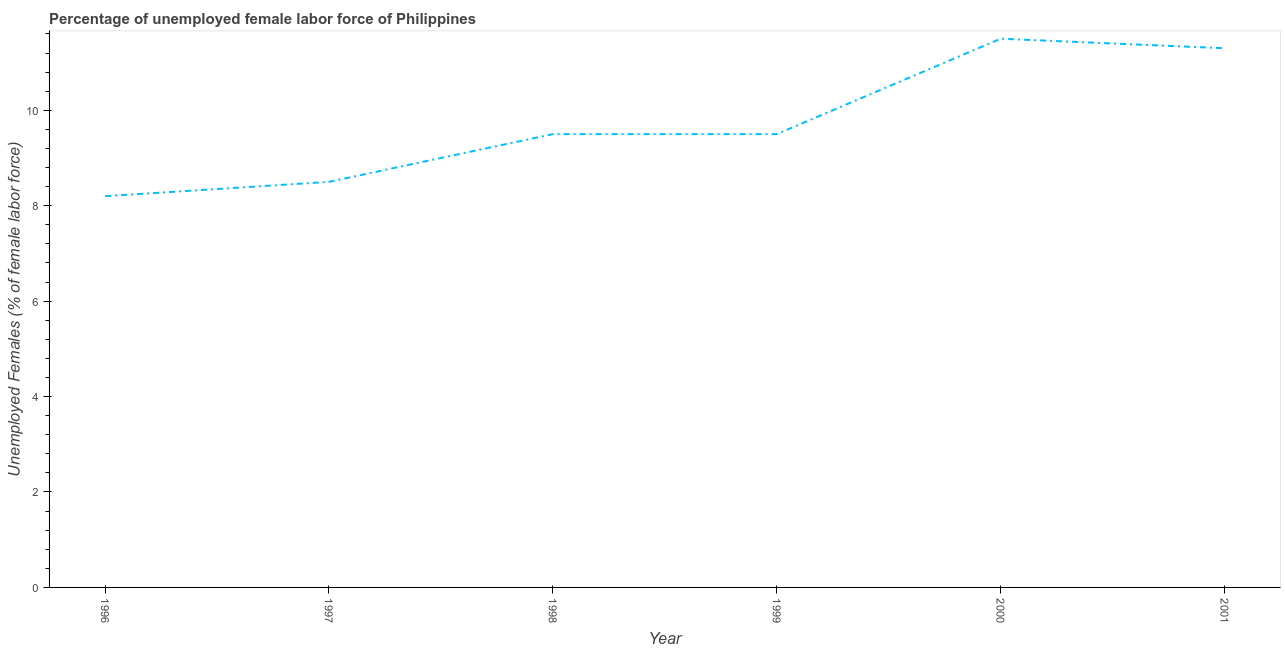What is the total unemployed female labour force in 2000?
Your response must be concise. 11.5. Across all years, what is the minimum total unemployed female labour force?
Offer a terse response. 8.2. What is the sum of the total unemployed female labour force?
Your answer should be compact. 58.5. What is the difference between the total unemployed female labour force in 1996 and 2000?
Your answer should be compact. -3.3. What is the average total unemployed female labour force per year?
Ensure brevity in your answer.  9.75. What is the median total unemployed female labour force?
Provide a short and direct response. 9.5. What is the ratio of the total unemployed female labour force in 1996 to that in 2000?
Offer a very short reply. 0.71. Is the total unemployed female labour force in 1999 less than that in 2001?
Offer a terse response. Yes. Is the difference between the total unemployed female labour force in 1996 and 1998 greater than the difference between any two years?
Offer a terse response. No. What is the difference between the highest and the second highest total unemployed female labour force?
Provide a succinct answer. 0.2. What is the difference between the highest and the lowest total unemployed female labour force?
Provide a succinct answer. 3.3. In how many years, is the total unemployed female labour force greater than the average total unemployed female labour force taken over all years?
Your answer should be very brief. 2. Does the total unemployed female labour force monotonically increase over the years?
Provide a succinct answer. No. How many lines are there?
Your answer should be compact. 1. Are the values on the major ticks of Y-axis written in scientific E-notation?
Your answer should be compact. No. Does the graph contain grids?
Your answer should be very brief. No. What is the title of the graph?
Make the answer very short. Percentage of unemployed female labor force of Philippines. What is the label or title of the Y-axis?
Provide a short and direct response. Unemployed Females (% of female labor force). What is the Unemployed Females (% of female labor force) of 1996?
Keep it short and to the point. 8.2. What is the Unemployed Females (% of female labor force) of 1997?
Offer a terse response. 8.5. What is the Unemployed Females (% of female labor force) in 1999?
Your response must be concise. 9.5. What is the Unemployed Females (% of female labor force) in 2000?
Your answer should be compact. 11.5. What is the Unemployed Females (% of female labor force) of 2001?
Provide a succinct answer. 11.3. What is the difference between the Unemployed Females (% of female labor force) in 1996 and 1997?
Your response must be concise. -0.3. What is the difference between the Unemployed Females (% of female labor force) in 1996 and 1998?
Give a very brief answer. -1.3. What is the difference between the Unemployed Females (% of female labor force) in 1996 and 1999?
Offer a terse response. -1.3. What is the difference between the Unemployed Females (% of female labor force) in 1997 and 1998?
Give a very brief answer. -1. What is the difference between the Unemployed Females (% of female labor force) in 1997 and 1999?
Provide a short and direct response. -1. What is the difference between the Unemployed Females (% of female labor force) in 1998 and 2000?
Offer a very short reply. -2. What is the difference between the Unemployed Females (% of female labor force) in 1999 and 2000?
Provide a short and direct response. -2. What is the ratio of the Unemployed Females (% of female labor force) in 1996 to that in 1998?
Your response must be concise. 0.86. What is the ratio of the Unemployed Females (% of female labor force) in 1996 to that in 1999?
Provide a succinct answer. 0.86. What is the ratio of the Unemployed Females (% of female labor force) in 1996 to that in 2000?
Provide a succinct answer. 0.71. What is the ratio of the Unemployed Females (% of female labor force) in 1996 to that in 2001?
Your answer should be very brief. 0.73. What is the ratio of the Unemployed Females (% of female labor force) in 1997 to that in 1998?
Make the answer very short. 0.9. What is the ratio of the Unemployed Females (% of female labor force) in 1997 to that in 1999?
Give a very brief answer. 0.9. What is the ratio of the Unemployed Females (% of female labor force) in 1997 to that in 2000?
Make the answer very short. 0.74. What is the ratio of the Unemployed Females (% of female labor force) in 1997 to that in 2001?
Make the answer very short. 0.75. What is the ratio of the Unemployed Females (% of female labor force) in 1998 to that in 2000?
Provide a succinct answer. 0.83. What is the ratio of the Unemployed Females (% of female labor force) in 1998 to that in 2001?
Make the answer very short. 0.84. What is the ratio of the Unemployed Females (% of female labor force) in 1999 to that in 2000?
Your answer should be compact. 0.83. What is the ratio of the Unemployed Females (% of female labor force) in 1999 to that in 2001?
Provide a short and direct response. 0.84. What is the ratio of the Unemployed Females (% of female labor force) in 2000 to that in 2001?
Your answer should be compact. 1.02. 